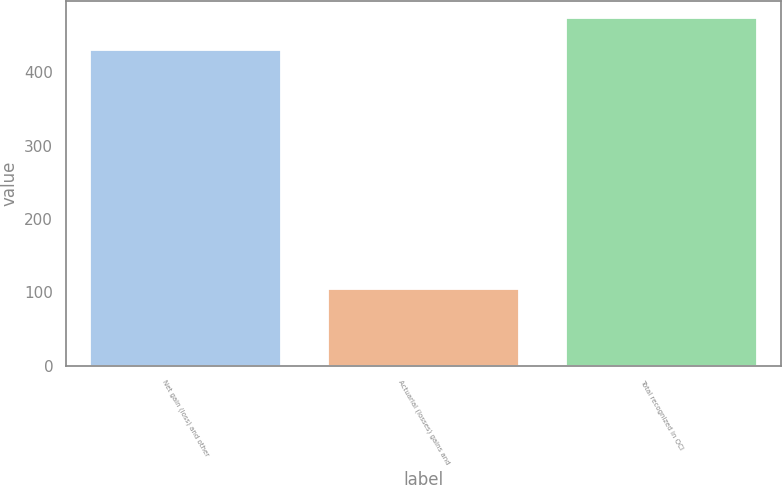<chart> <loc_0><loc_0><loc_500><loc_500><bar_chart><fcel>Net gain (loss) and other<fcel>Actuarial (losses) gains and<fcel>Total recognized in OCI<nl><fcel>430<fcel>104<fcel>474<nl></chart> 